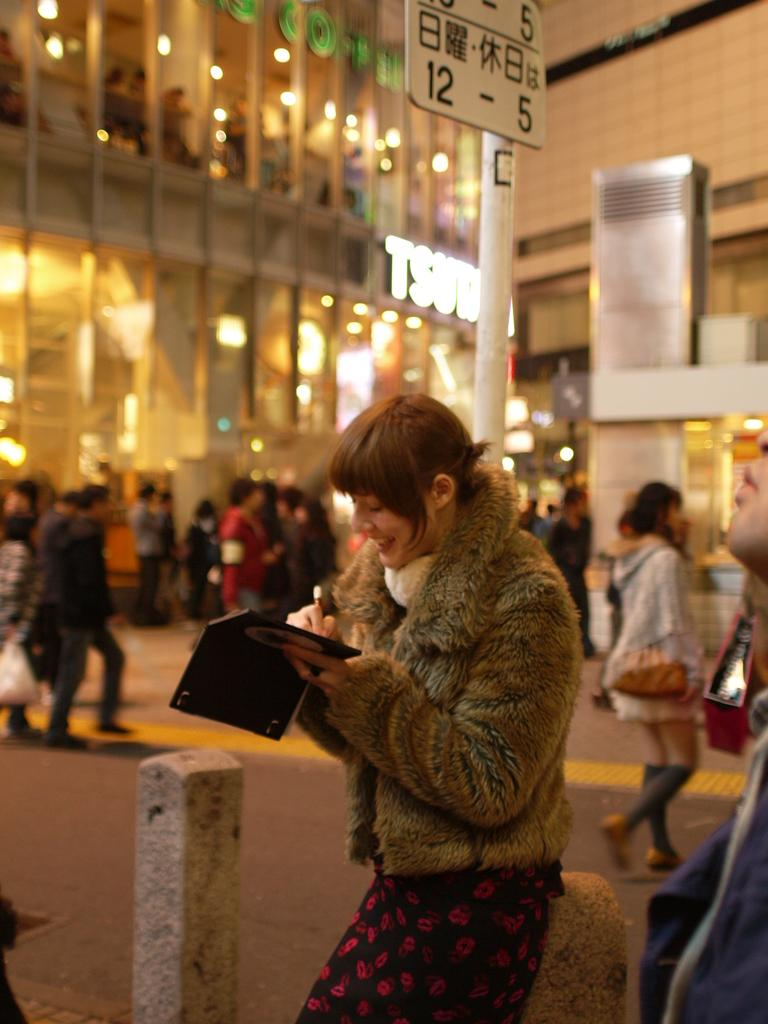What is happening on the road in the image? There are people on the road in the image. What can be seen in the distance behind the people? There are buildings, lights, glasses, a pole, and boards visible in the background of the image. How does the respect for growth manifest itself in the image? There is no indication of respect for growth in the image; it features people on the road and various objects in the background. 